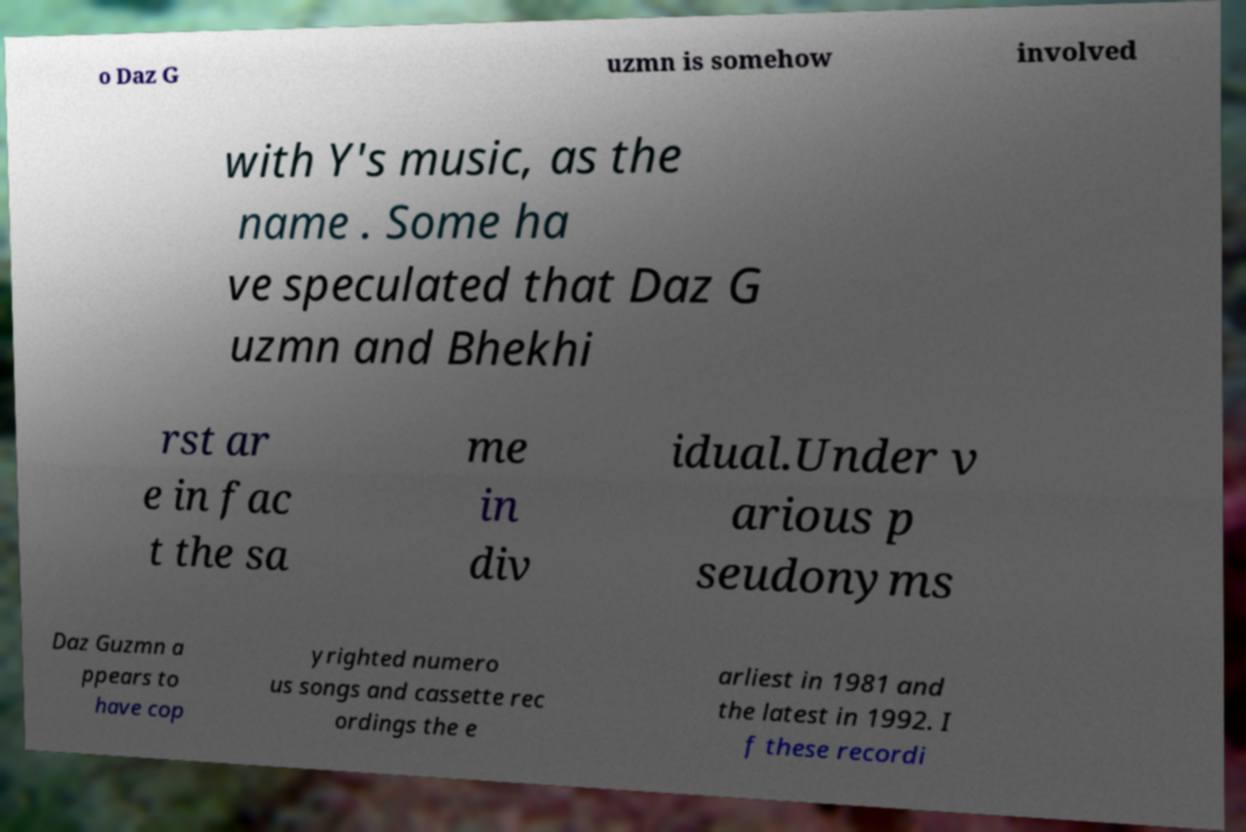Can you accurately transcribe the text from the provided image for me? o Daz G uzmn is somehow involved with Y's music, as the name . Some ha ve speculated that Daz G uzmn and Bhekhi rst ar e in fac t the sa me in div idual.Under v arious p seudonyms Daz Guzmn a ppears to have cop yrighted numero us songs and cassette rec ordings the e arliest in 1981 and the latest in 1992. I f these recordi 